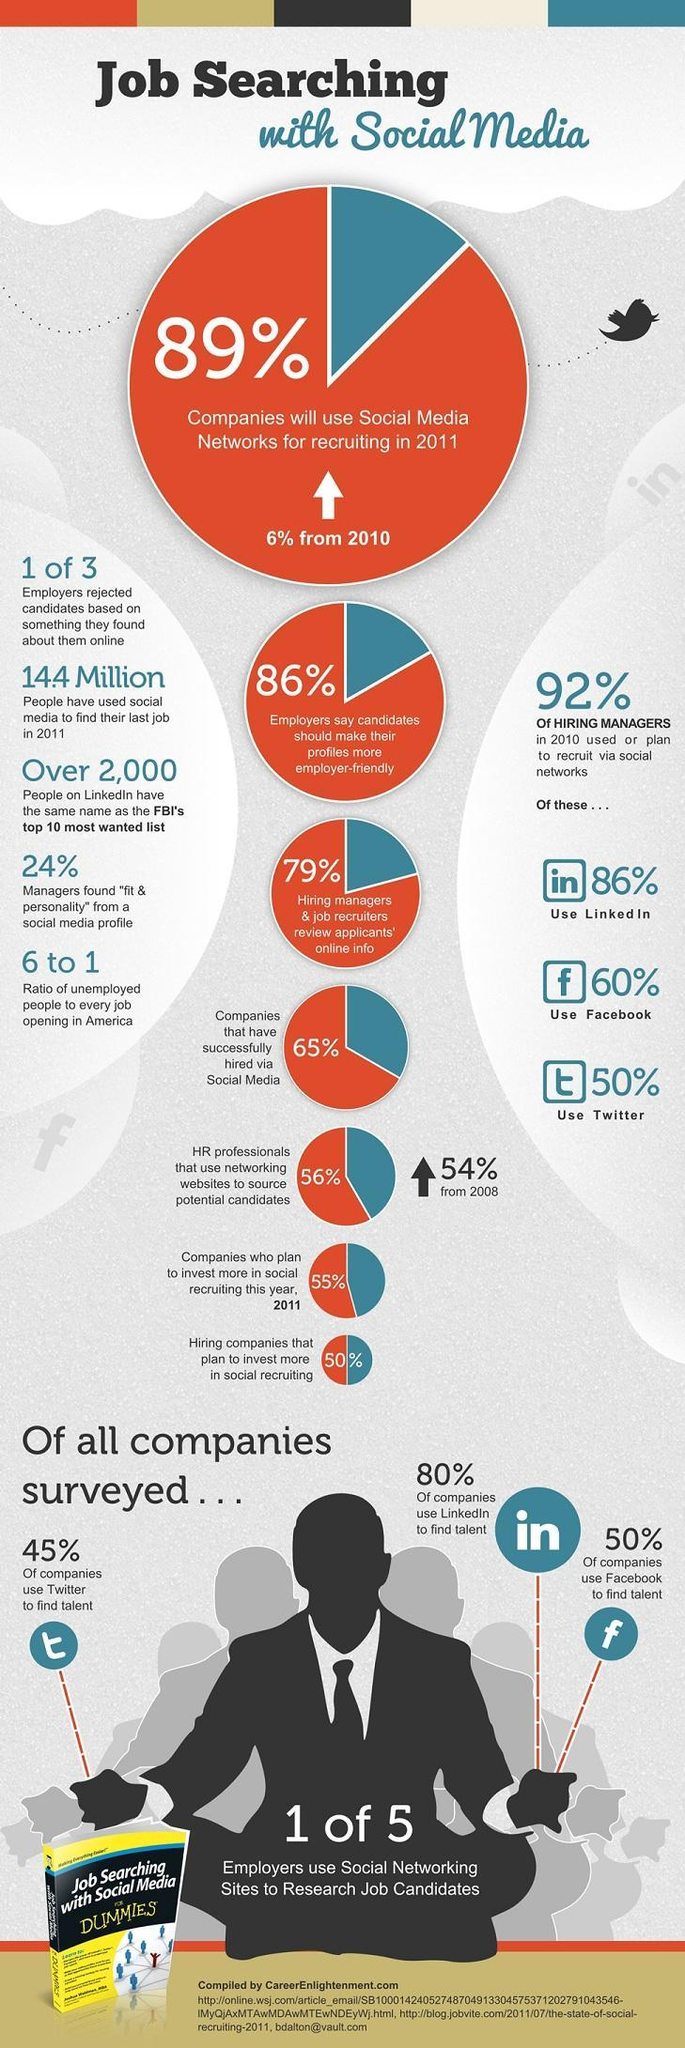What is the title of the book?
Answer the question with a short phrase. Job Searching with Social Media FOR DUMMIES What percent of companies are not using social media for recruiting? 11% 